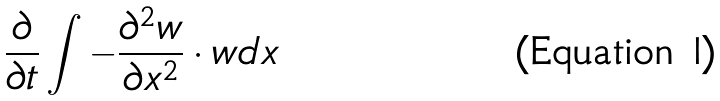<formula> <loc_0><loc_0><loc_500><loc_500>\frac { \partial } { \partial t } \int - \frac { \partial ^ { 2 } w } { \partial x ^ { 2 } } \cdot w d x</formula> 